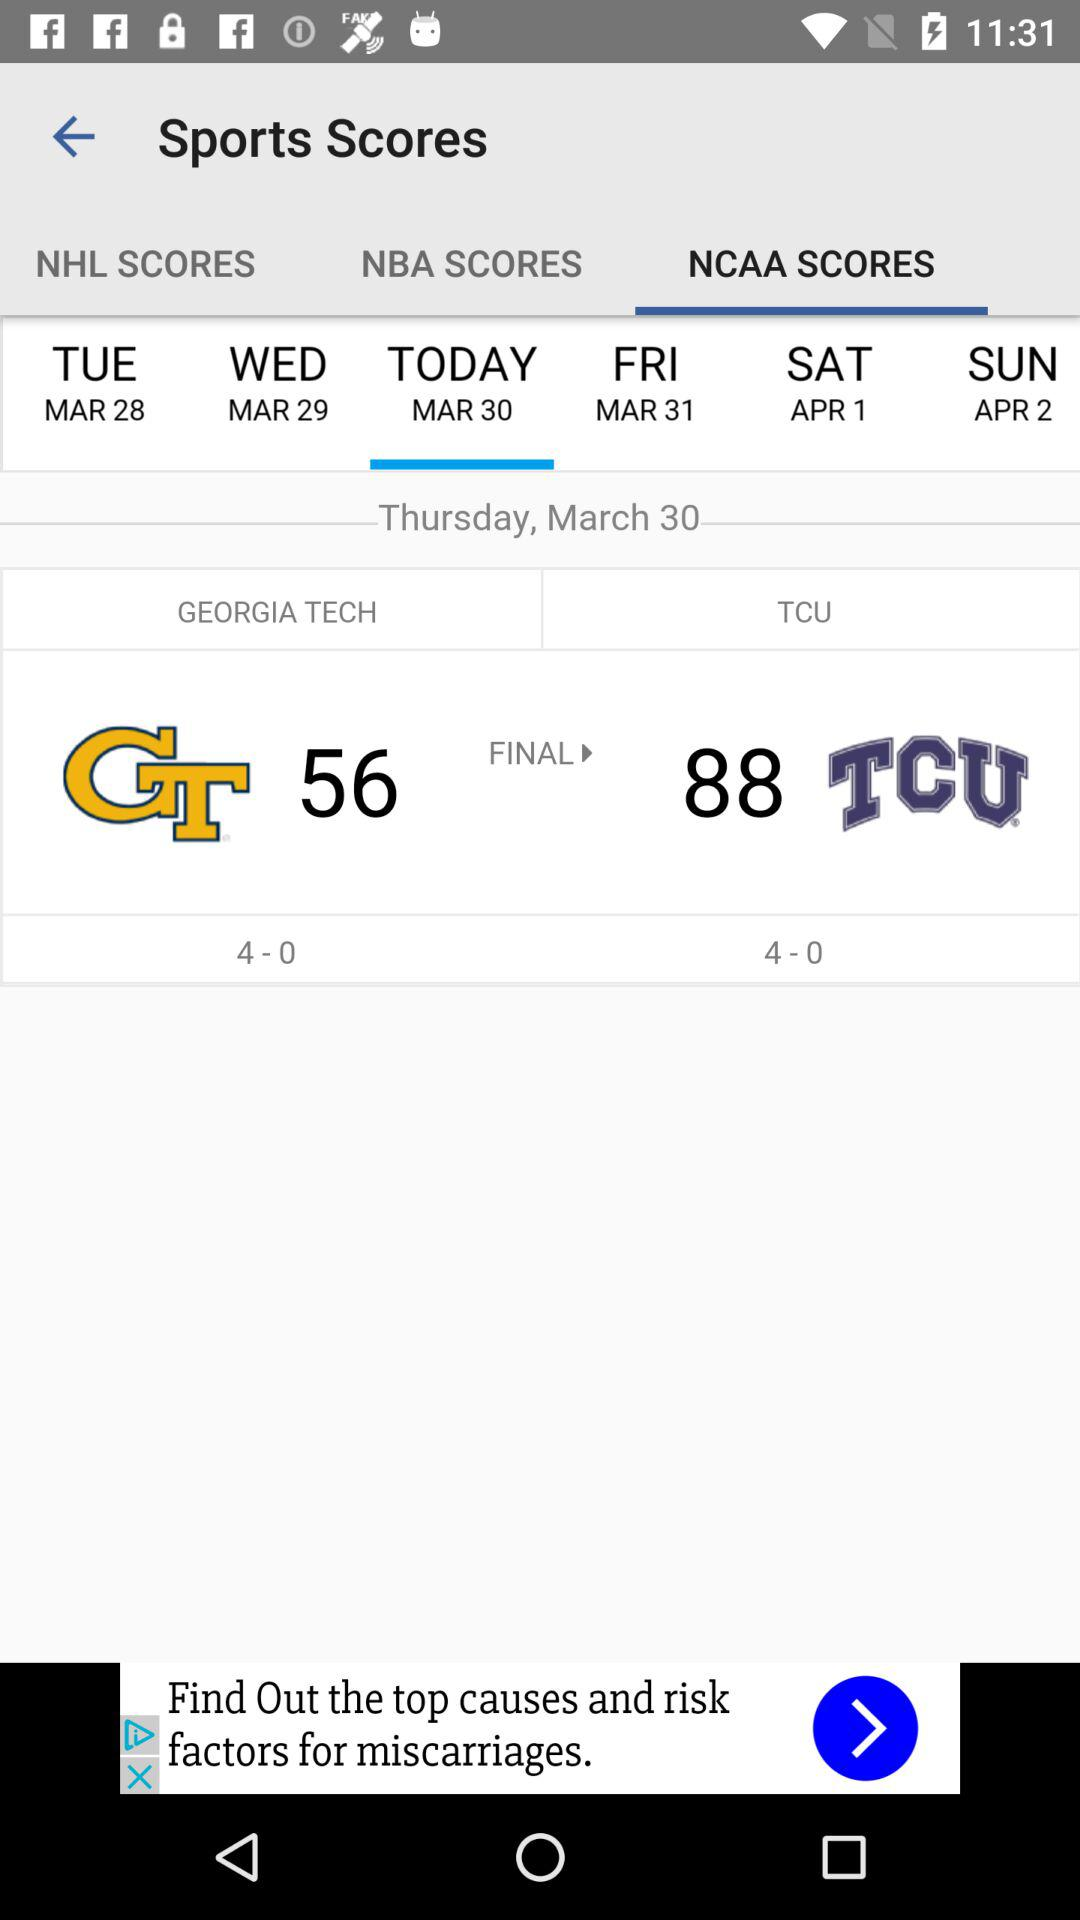What is the selected option? The selected option is "NCAA SCORES". 